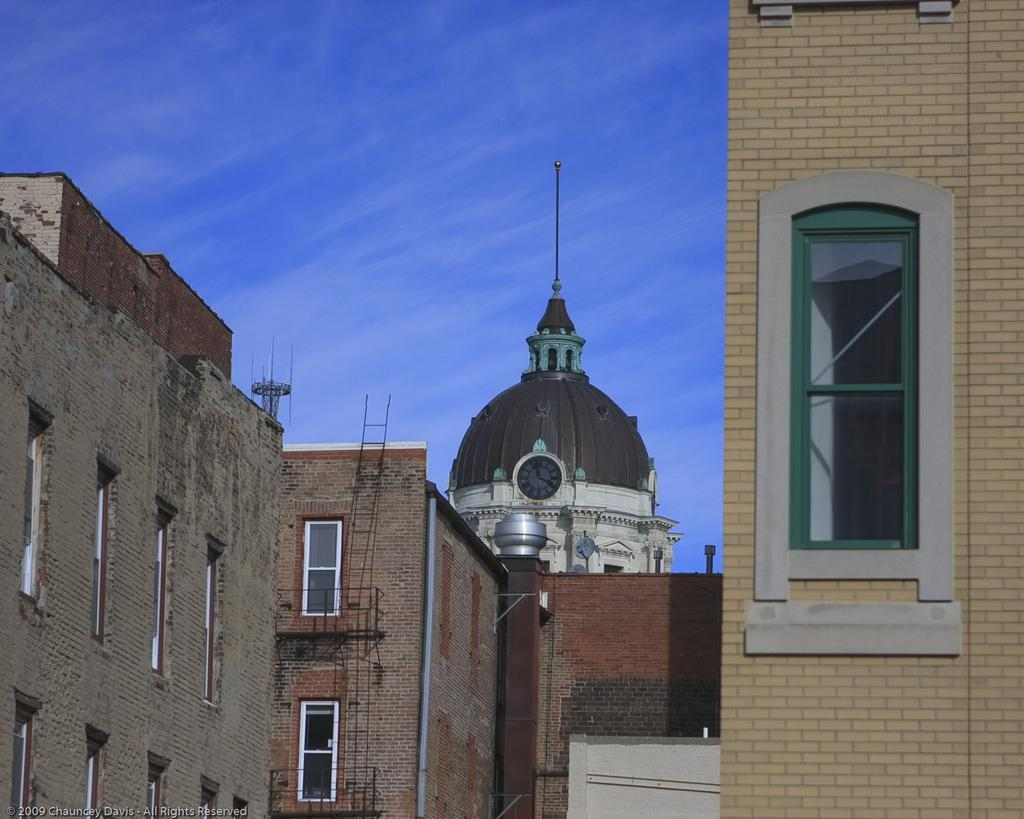What type of structures can be seen in the image? There are buildings in the image. What specific feature can be identified in the background of the image? There is a clock tower in the background of the image. What is visible at the top of the image? The sky is visible at the top of the image. Can you describe any other objects present in the image? There are other objects present in the image, but their specific details are not mentioned in the provided facts. How many cakes are being served at the question session in the image? There is no mention of cakes or a question session in the image, so it is not possible to answer that question. 